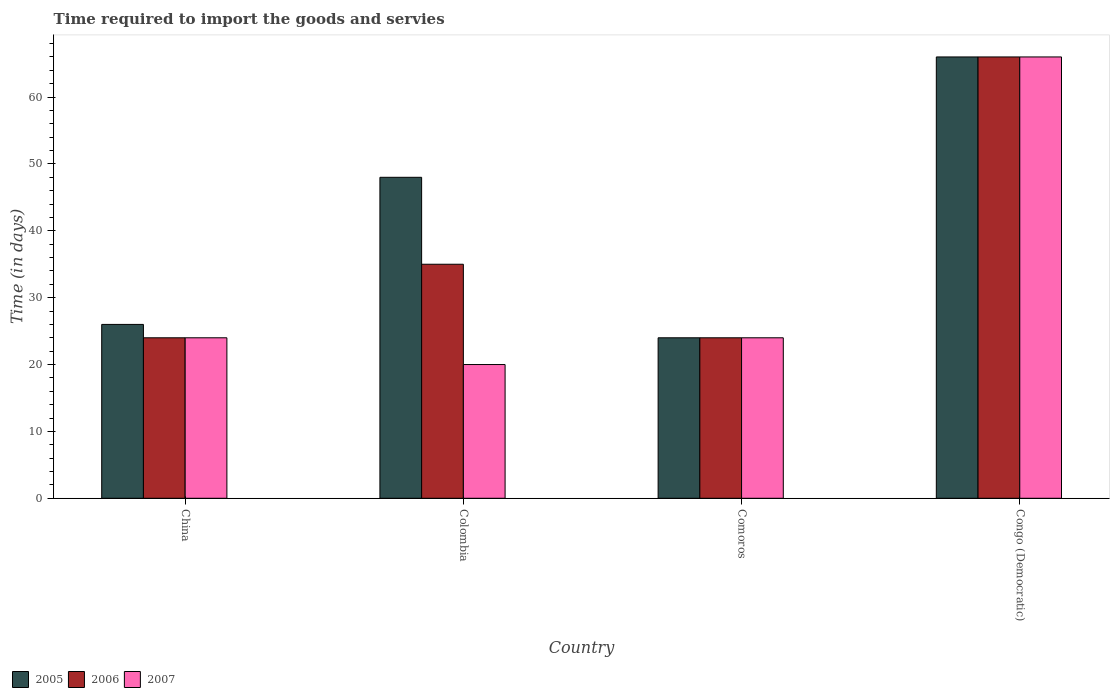How many groups of bars are there?
Give a very brief answer. 4. What is the label of the 2nd group of bars from the left?
Provide a succinct answer. Colombia. In how many cases, is the number of bars for a given country not equal to the number of legend labels?
Offer a very short reply. 0. What is the number of days required to import the goods and services in 2006 in Comoros?
Make the answer very short. 24. Across all countries, what is the minimum number of days required to import the goods and services in 2007?
Ensure brevity in your answer.  20. In which country was the number of days required to import the goods and services in 2005 maximum?
Make the answer very short. Congo (Democratic). What is the total number of days required to import the goods and services in 2005 in the graph?
Your answer should be compact. 164. What is the difference between the number of days required to import the goods and services in 2005 in Comoros and the number of days required to import the goods and services in 2007 in Colombia?
Provide a succinct answer. 4. What is the difference between the number of days required to import the goods and services of/in 2005 and number of days required to import the goods and services of/in 2007 in Colombia?
Your answer should be compact. 28. In how many countries, is the number of days required to import the goods and services in 2005 greater than 64 days?
Your response must be concise. 1. What is the ratio of the number of days required to import the goods and services in 2007 in China to that in Comoros?
Provide a succinct answer. 1. Is the number of days required to import the goods and services in 2007 in China less than that in Congo (Democratic)?
Ensure brevity in your answer.  Yes. Is the difference between the number of days required to import the goods and services in 2005 in China and Congo (Democratic) greater than the difference between the number of days required to import the goods and services in 2007 in China and Congo (Democratic)?
Give a very brief answer. Yes. What is the difference between the highest and the second highest number of days required to import the goods and services in 2007?
Provide a short and direct response. -42. What is the difference between the highest and the lowest number of days required to import the goods and services in 2007?
Your response must be concise. 46. Is the sum of the number of days required to import the goods and services in 2005 in China and Comoros greater than the maximum number of days required to import the goods and services in 2007 across all countries?
Ensure brevity in your answer.  No. What does the 3rd bar from the right in Comoros represents?
Your response must be concise. 2005. Is it the case that in every country, the sum of the number of days required to import the goods and services in 2005 and number of days required to import the goods and services in 2006 is greater than the number of days required to import the goods and services in 2007?
Your answer should be very brief. Yes. How many bars are there?
Your answer should be compact. 12. Are all the bars in the graph horizontal?
Your response must be concise. No. Where does the legend appear in the graph?
Your response must be concise. Bottom left. How are the legend labels stacked?
Offer a very short reply. Horizontal. What is the title of the graph?
Provide a succinct answer. Time required to import the goods and servies. What is the label or title of the Y-axis?
Make the answer very short. Time (in days). What is the Time (in days) of 2005 in China?
Ensure brevity in your answer.  26. What is the Time (in days) in 2007 in China?
Make the answer very short. 24. What is the Time (in days) of 2005 in Colombia?
Give a very brief answer. 48. What is the Time (in days) of 2005 in Congo (Democratic)?
Ensure brevity in your answer.  66. What is the Time (in days) of 2007 in Congo (Democratic)?
Your answer should be very brief. 66. Across all countries, what is the maximum Time (in days) in 2006?
Provide a succinct answer. 66. Across all countries, what is the maximum Time (in days) in 2007?
Provide a short and direct response. 66. Across all countries, what is the minimum Time (in days) of 2007?
Your response must be concise. 20. What is the total Time (in days) of 2005 in the graph?
Provide a short and direct response. 164. What is the total Time (in days) in 2006 in the graph?
Offer a very short reply. 149. What is the total Time (in days) in 2007 in the graph?
Offer a terse response. 134. What is the difference between the Time (in days) of 2005 in China and that in Colombia?
Keep it short and to the point. -22. What is the difference between the Time (in days) of 2006 in China and that in Colombia?
Provide a succinct answer. -11. What is the difference between the Time (in days) in 2007 in China and that in Colombia?
Give a very brief answer. 4. What is the difference between the Time (in days) of 2005 in China and that in Comoros?
Your answer should be very brief. 2. What is the difference between the Time (in days) in 2005 in China and that in Congo (Democratic)?
Offer a terse response. -40. What is the difference between the Time (in days) in 2006 in China and that in Congo (Democratic)?
Ensure brevity in your answer.  -42. What is the difference between the Time (in days) of 2007 in China and that in Congo (Democratic)?
Offer a very short reply. -42. What is the difference between the Time (in days) in 2006 in Colombia and that in Comoros?
Your answer should be compact. 11. What is the difference between the Time (in days) in 2006 in Colombia and that in Congo (Democratic)?
Provide a short and direct response. -31. What is the difference between the Time (in days) of 2007 in Colombia and that in Congo (Democratic)?
Make the answer very short. -46. What is the difference between the Time (in days) of 2005 in Comoros and that in Congo (Democratic)?
Your response must be concise. -42. What is the difference between the Time (in days) in 2006 in Comoros and that in Congo (Democratic)?
Provide a short and direct response. -42. What is the difference between the Time (in days) in 2007 in Comoros and that in Congo (Democratic)?
Offer a terse response. -42. What is the difference between the Time (in days) in 2005 in China and the Time (in days) in 2007 in Colombia?
Ensure brevity in your answer.  6. What is the difference between the Time (in days) in 2006 in China and the Time (in days) in 2007 in Colombia?
Keep it short and to the point. 4. What is the difference between the Time (in days) in 2005 in China and the Time (in days) in 2007 in Congo (Democratic)?
Your response must be concise. -40. What is the difference between the Time (in days) in 2006 in China and the Time (in days) in 2007 in Congo (Democratic)?
Your answer should be very brief. -42. What is the difference between the Time (in days) in 2005 in Colombia and the Time (in days) in 2007 in Comoros?
Offer a terse response. 24. What is the difference between the Time (in days) in 2006 in Colombia and the Time (in days) in 2007 in Comoros?
Your answer should be very brief. 11. What is the difference between the Time (in days) in 2005 in Colombia and the Time (in days) in 2006 in Congo (Democratic)?
Provide a short and direct response. -18. What is the difference between the Time (in days) in 2005 in Colombia and the Time (in days) in 2007 in Congo (Democratic)?
Offer a terse response. -18. What is the difference between the Time (in days) in 2006 in Colombia and the Time (in days) in 2007 in Congo (Democratic)?
Provide a succinct answer. -31. What is the difference between the Time (in days) of 2005 in Comoros and the Time (in days) of 2006 in Congo (Democratic)?
Your answer should be very brief. -42. What is the difference between the Time (in days) of 2005 in Comoros and the Time (in days) of 2007 in Congo (Democratic)?
Offer a very short reply. -42. What is the difference between the Time (in days) in 2006 in Comoros and the Time (in days) in 2007 in Congo (Democratic)?
Provide a short and direct response. -42. What is the average Time (in days) of 2005 per country?
Provide a short and direct response. 41. What is the average Time (in days) in 2006 per country?
Keep it short and to the point. 37.25. What is the average Time (in days) in 2007 per country?
Your answer should be very brief. 33.5. What is the difference between the Time (in days) of 2005 and Time (in days) of 2007 in China?
Give a very brief answer. 2. What is the difference between the Time (in days) of 2006 and Time (in days) of 2007 in China?
Keep it short and to the point. 0. What is the difference between the Time (in days) of 2006 and Time (in days) of 2007 in Comoros?
Offer a very short reply. 0. What is the difference between the Time (in days) in 2005 and Time (in days) in 2006 in Congo (Democratic)?
Ensure brevity in your answer.  0. What is the difference between the Time (in days) of 2005 and Time (in days) of 2007 in Congo (Democratic)?
Ensure brevity in your answer.  0. What is the ratio of the Time (in days) of 2005 in China to that in Colombia?
Offer a terse response. 0.54. What is the ratio of the Time (in days) in 2006 in China to that in Colombia?
Your answer should be very brief. 0.69. What is the ratio of the Time (in days) in 2007 in China to that in Colombia?
Your response must be concise. 1.2. What is the ratio of the Time (in days) in 2005 in China to that in Comoros?
Offer a very short reply. 1.08. What is the ratio of the Time (in days) of 2005 in China to that in Congo (Democratic)?
Offer a terse response. 0.39. What is the ratio of the Time (in days) in 2006 in China to that in Congo (Democratic)?
Your answer should be very brief. 0.36. What is the ratio of the Time (in days) of 2007 in China to that in Congo (Democratic)?
Make the answer very short. 0.36. What is the ratio of the Time (in days) of 2006 in Colombia to that in Comoros?
Your answer should be compact. 1.46. What is the ratio of the Time (in days) in 2005 in Colombia to that in Congo (Democratic)?
Your response must be concise. 0.73. What is the ratio of the Time (in days) in 2006 in Colombia to that in Congo (Democratic)?
Keep it short and to the point. 0.53. What is the ratio of the Time (in days) in 2007 in Colombia to that in Congo (Democratic)?
Ensure brevity in your answer.  0.3. What is the ratio of the Time (in days) of 2005 in Comoros to that in Congo (Democratic)?
Your answer should be very brief. 0.36. What is the ratio of the Time (in days) in 2006 in Comoros to that in Congo (Democratic)?
Give a very brief answer. 0.36. What is the ratio of the Time (in days) of 2007 in Comoros to that in Congo (Democratic)?
Provide a succinct answer. 0.36. What is the difference between the highest and the lowest Time (in days) of 2005?
Give a very brief answer. 42. What is the difference between the highest and the lowest Time (in days) in 2006?
Your answer should be very brief. 42. 